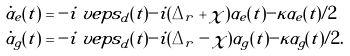<formula> <loc_0><loc_0><loc_500><loc_500>\dot { \alpha } _ { e } ( t ) & = - i \ v e p s _ { d } ( t ) - i ( \Delta _ { r } + \chi ) \alpha _ { e } ( t ) - \kappa \alpha _ { e } ( t ) / 2 \\ \dot { \alpha } _ { g } ( t ) & = - i \ v e p s _ { d } ( t ) - i ( \Delta _ { r } - \chi ) \alpha _ { g } ( t ) - \kappa \alpha _ { g } ( t ) / 2 .</formula> 